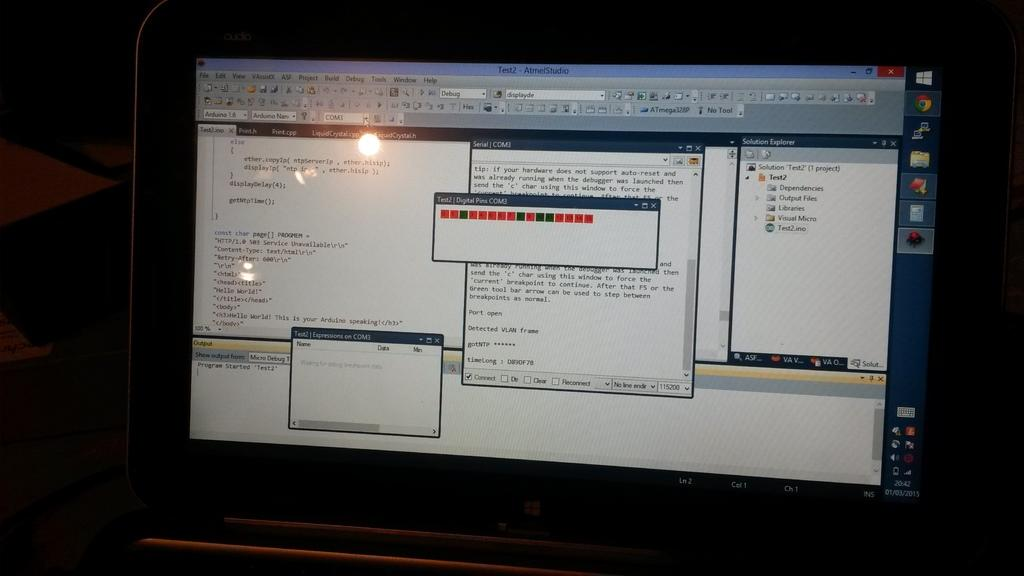<image>
Describe the image concisely. a computer monitor open to a screen entitled Test2 Atmel Studio 